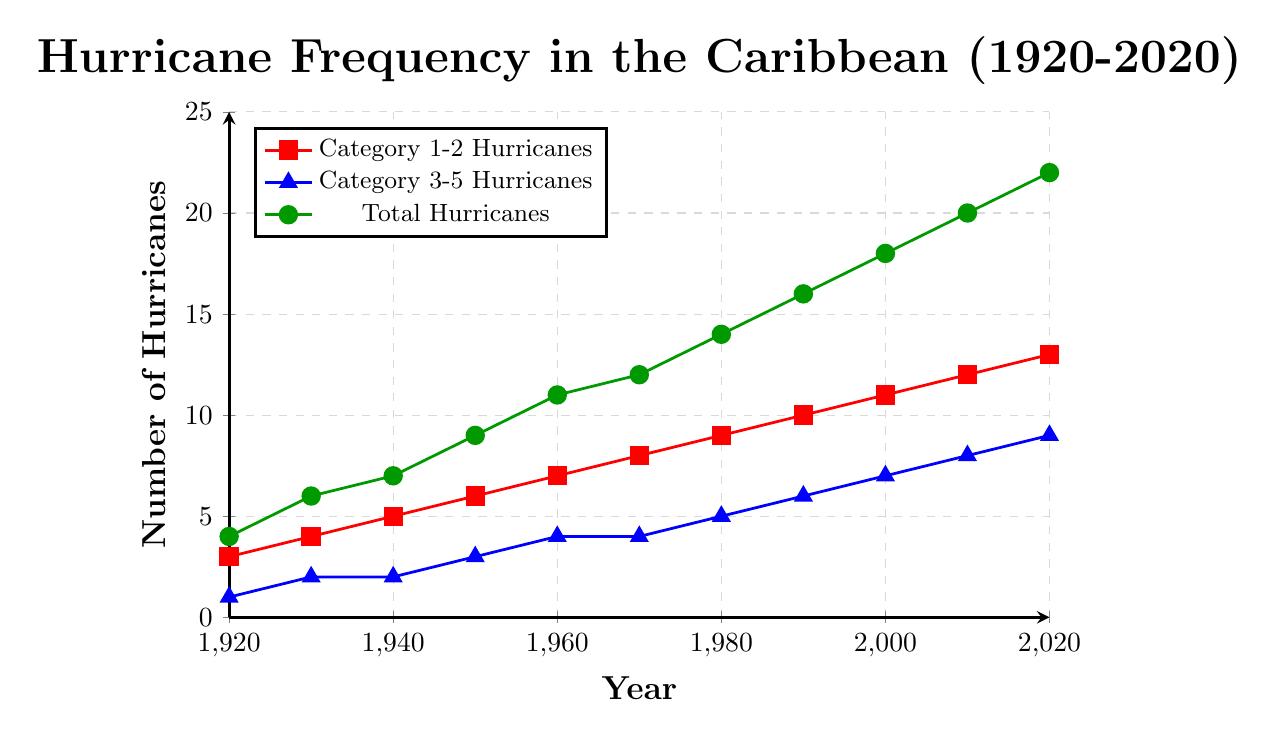What's the total number of hurricanes in 1960? According to the graph, the 'Total Hurricanes' series (green) shows 11 hurricanes in 1960.
Answer: 11 Which year had more Category 3-5 Hurricanes, 1940 or 1950? In 1940, there were 2 Category 3-5 Hurricanes, while in 1950, there were 3. Therefore, 1950 had more Category 3-5 Hurricanes.
Answer: 1950 By how much did the total number of hurricanes increase from 1920 to 2020? The total number of hurricanes in 1920 was 4 and in 2020 it was 22. The increase is 22 - 4 = 18.
Answer: 18 Compare the frequency of Category 1-2 Hurricanes and Category 3-5 Hurricanes in 2000. Which category had more hurricanes, and by how many? In 2000, there were 11 Category 1-2 Hurricanes and 7 Category 3-5 Hurricanes. Hence, there were 11 - 7 = 4 more Category 1-2 Hurricanes.
Answer: Category 1-2 Hurricanes by 4 What trend can be observed in the total number of hurricanes over the century? The total number of hurricanes has consistently increased from 1920 to 2020. This is shown by a steady upward trend in the green line representing 'Total Hurricanes'.
Answer: Increasing trend How many Category 1-2 Hurricanes were there on average per decade from 1920 to 2020? To find the average: Summing Category 1-2 Hurricanes (3 + 4 + 5 + 6 + 7 + 8 + 9 + 10 + 11 + 12 + 13) = 88. There are 11 decades from 1920 to 2020. Average = 88/11 = 8.
Answer: 8 Which year recorded the highest number of Category 3-5 Hurricanes? The highest number of Category 3-5 Hurricanes, 9, occurred in 2020 according to the blue line.
Answer: 2020 In which decades did the number of Total Hurricanes see a significant jump compared to the previous decade? The decades 1950, 1960, and 1980 saw considerable increases compared to their preceding decades: 1950 (9 vs. 7 in 1940), 1960 (11 vs. 9 in 1950), and 1980 (14 vs. 12 in 1970).
Answer: 1950, 1960, 1980 How does the visual representation of Category 1-2 Hurricanes differ from Category 3-5 Hurricanes in the graph? Category 1-2 Hurricanes are shown with red square marks, while Category 3-5 Hurricanes are depicted with blue triangle marks.
Answer: Different color and shape markers 